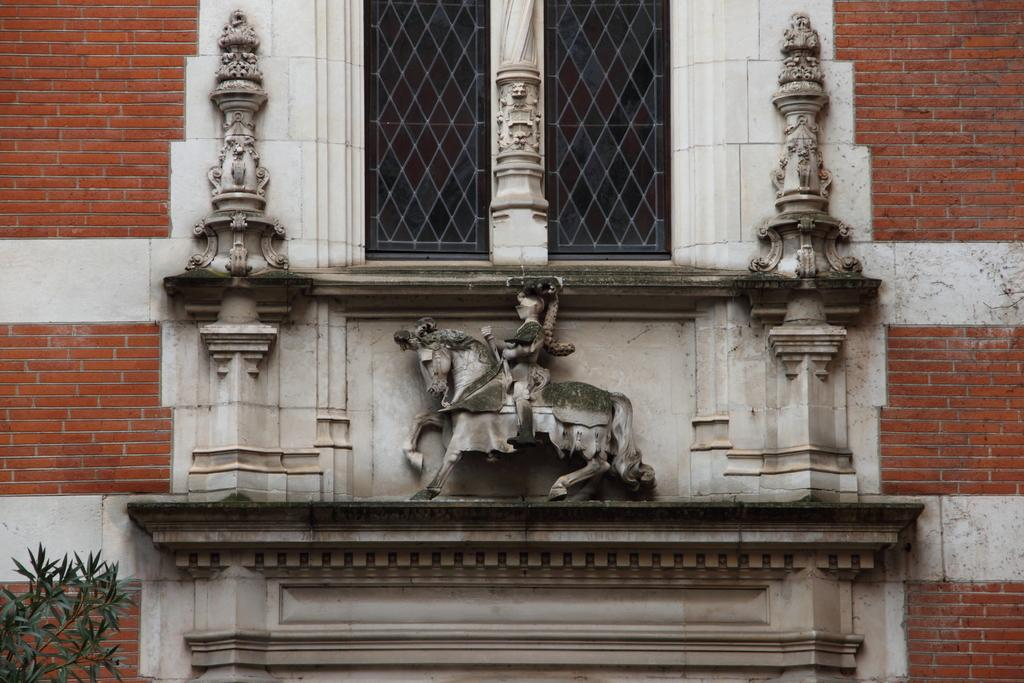What is the main subject in the center of the image? There is a statue in the center of the image. What can be seen in the background of the image? There is a building and a window in the background of the image. Where is the plant located in the image? The plant is at the bottom left corner of the image. What type of book is being used to clean the dust off the statue in the image? There is no book or dust present in the image; it features a statue, a building, a window, and a plant. 